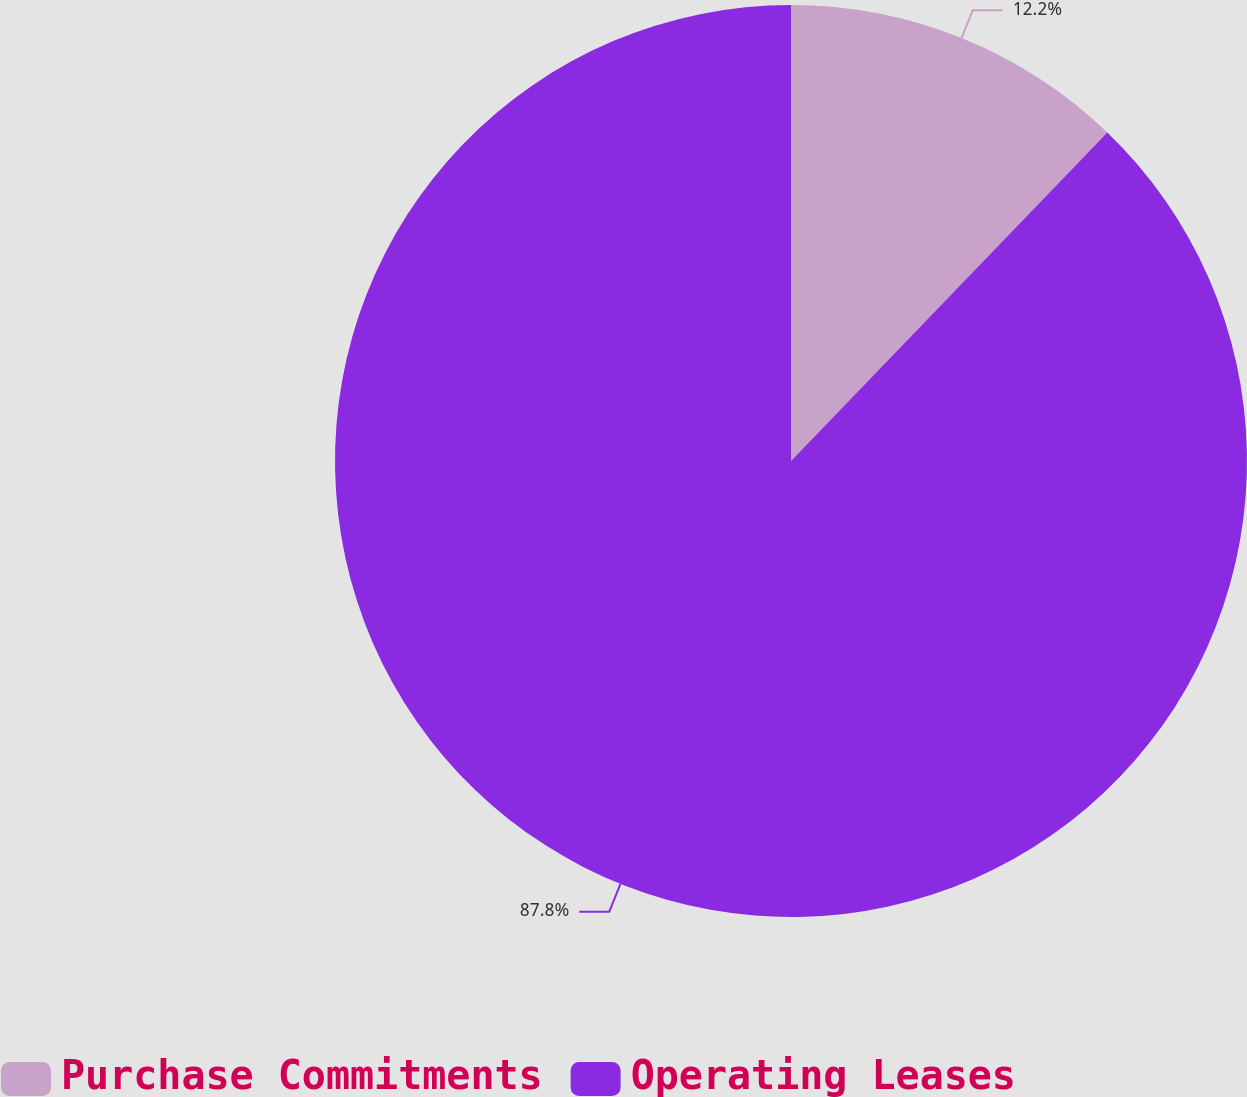Convert chart to OTSL. <chart><loc_0><loc_0><loc_500><loc_500><pie_chart><fcel>Purchase Commitments<fcel>Operating Leases<nl><fcel>12.2%<fcel>87.8%<nl></chart> 